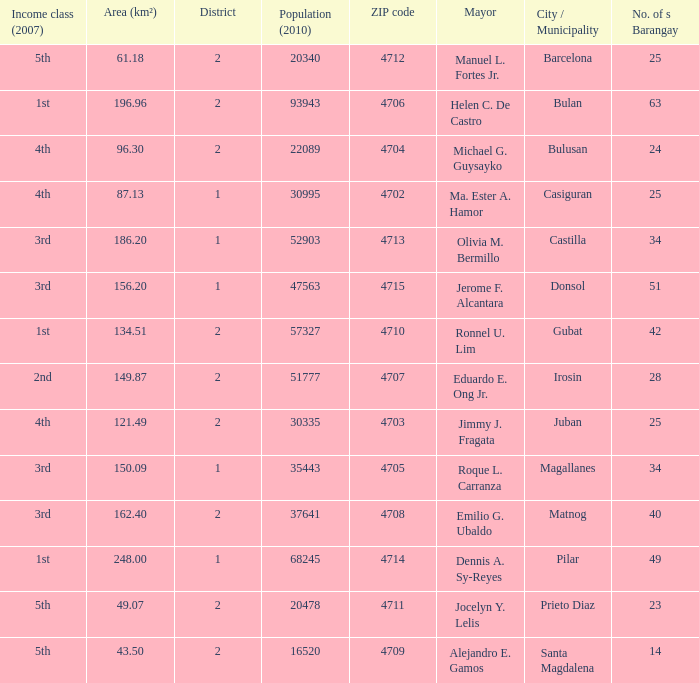What are all the vicinity (km²) where profits magnificence (2007) is 2nd 149.87. 